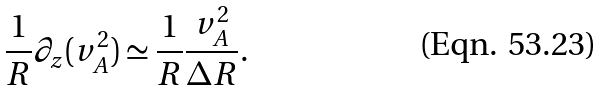<formula> <loc_0><loc_0><loc_500><loc_500>\frac { 1 } { R } \partial _ { z } ( v _ { A } ^ { 2 } ) \simeq \frac { 1 } { R } \frac { v _ { A } ^ { 2 } } { \Delta R } .</formula> 